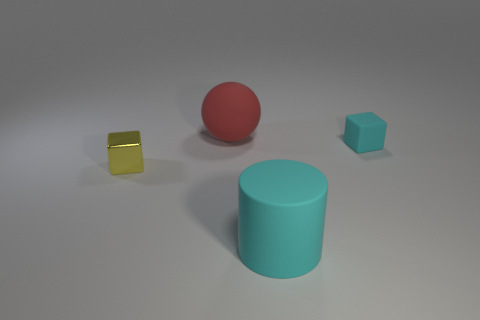Add 3 red rubber spheres. How many objects exist? 7 Subtract all yellow cubes. How many cubes are left? 1 Subtract all balls. How many objects are left? 3 Subtract all big red metallic things. Subtract all cyan objects. How many objects are left? 2 Add 4 big things. How many big things are left? 6 Add 2 large blue spheres. How many large blue spheres exist? 2 Subtract 0 red cylinders. How many objects are left? 4 Subtract all gray blocks. Subtract all brown spheres. How many blocks are left? 2 Subtract all cyan cylinders. How many red cubes are left? 0 